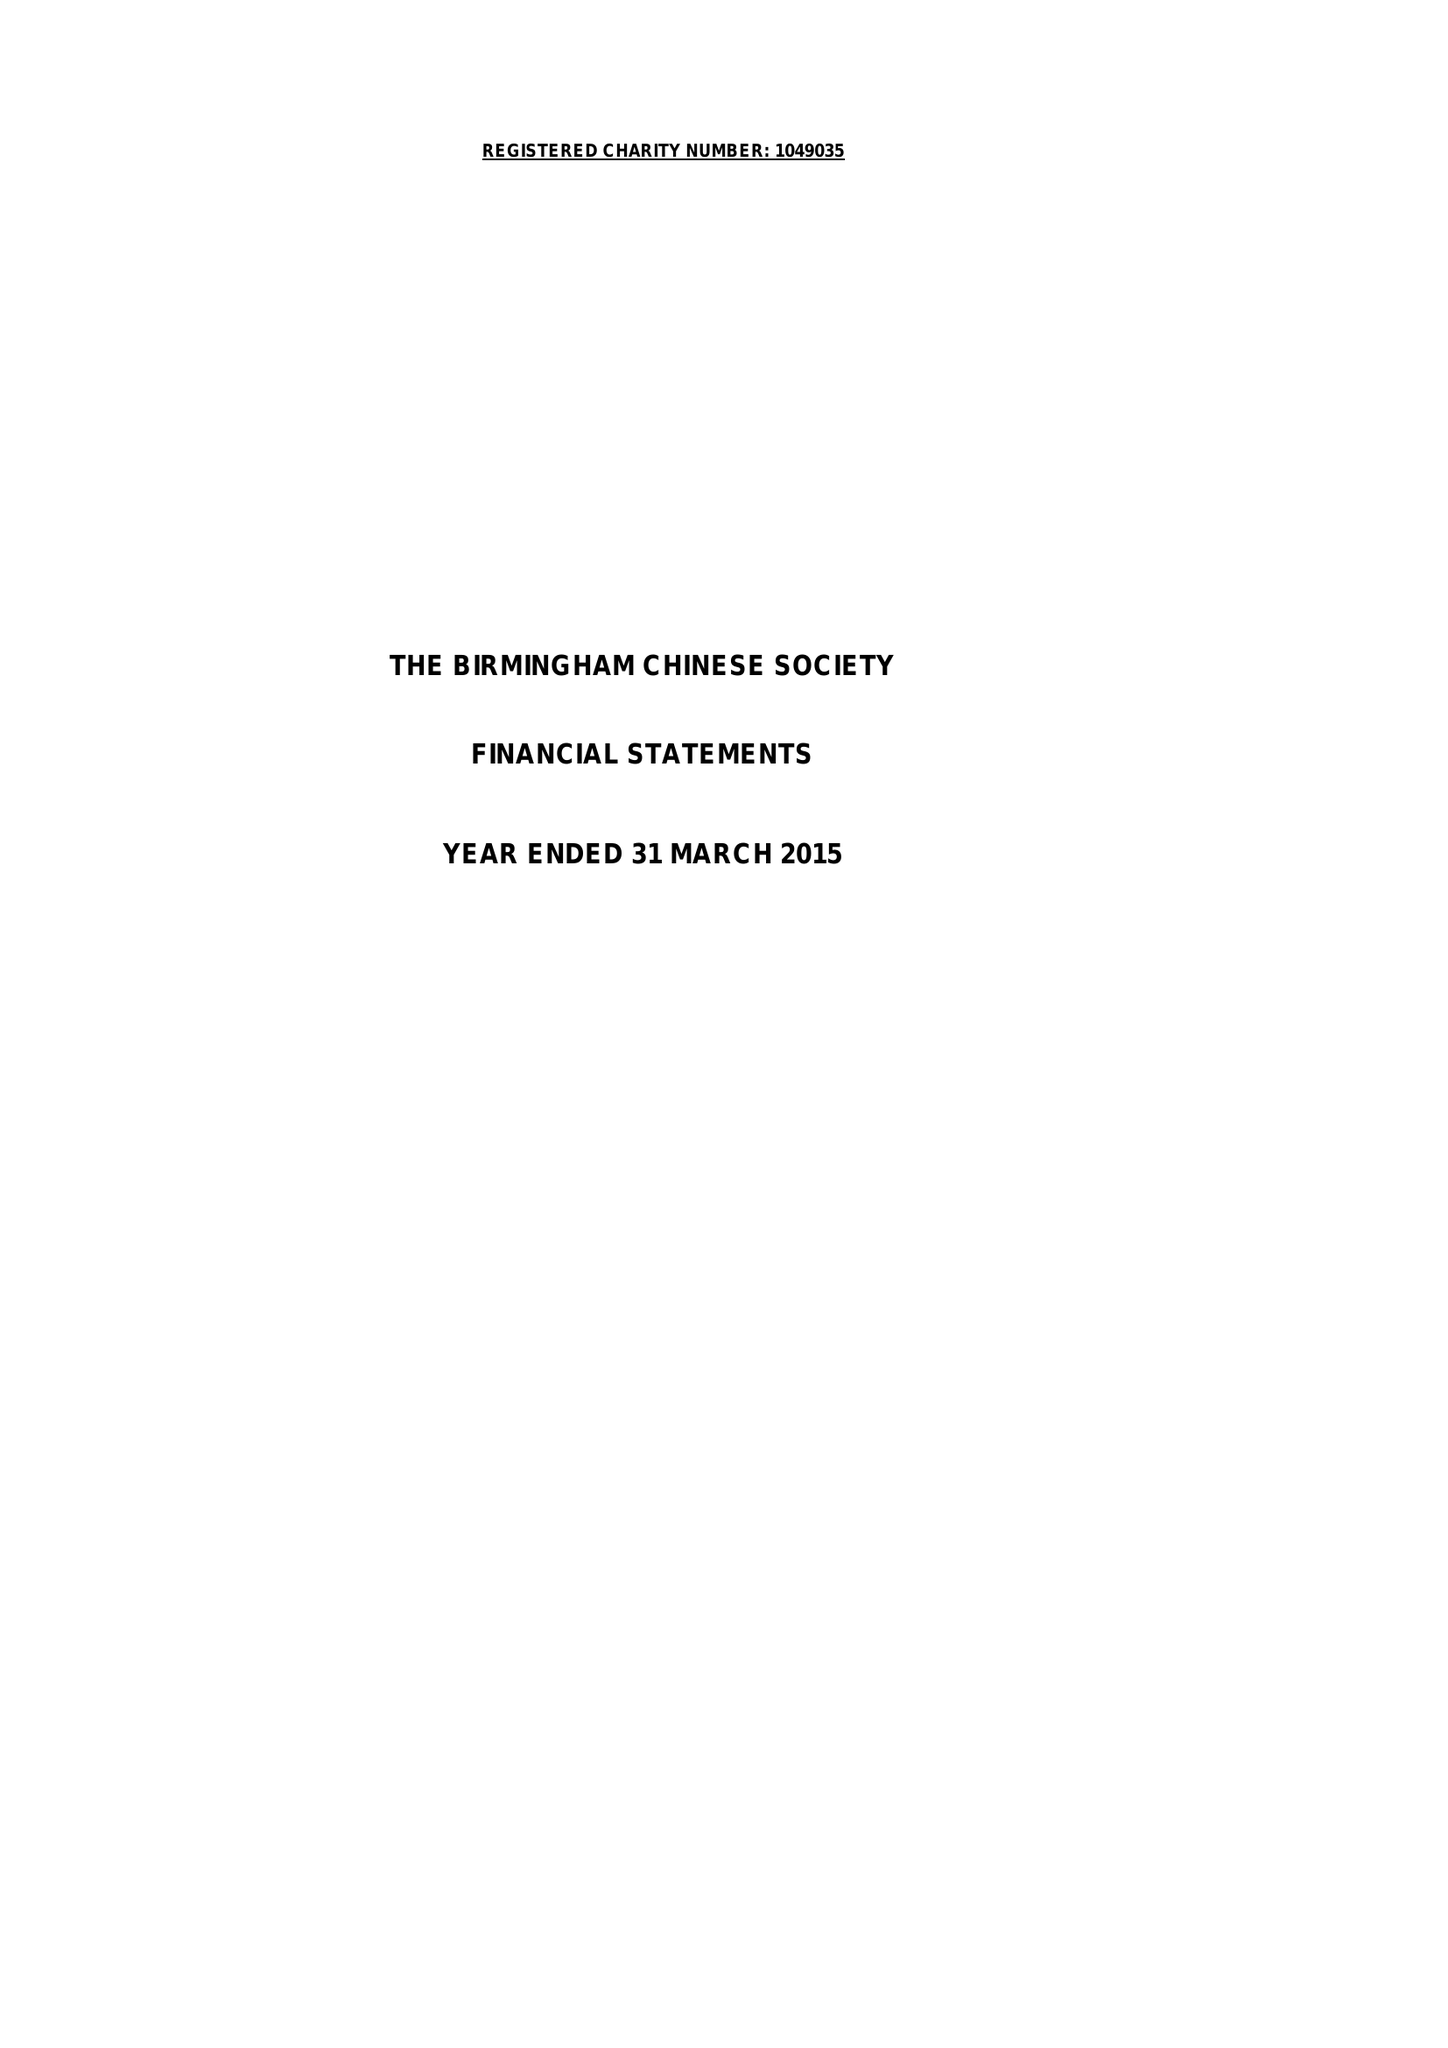What is the value for the report_date?
Answer the question using a single word or phrase. 2015-03-31 